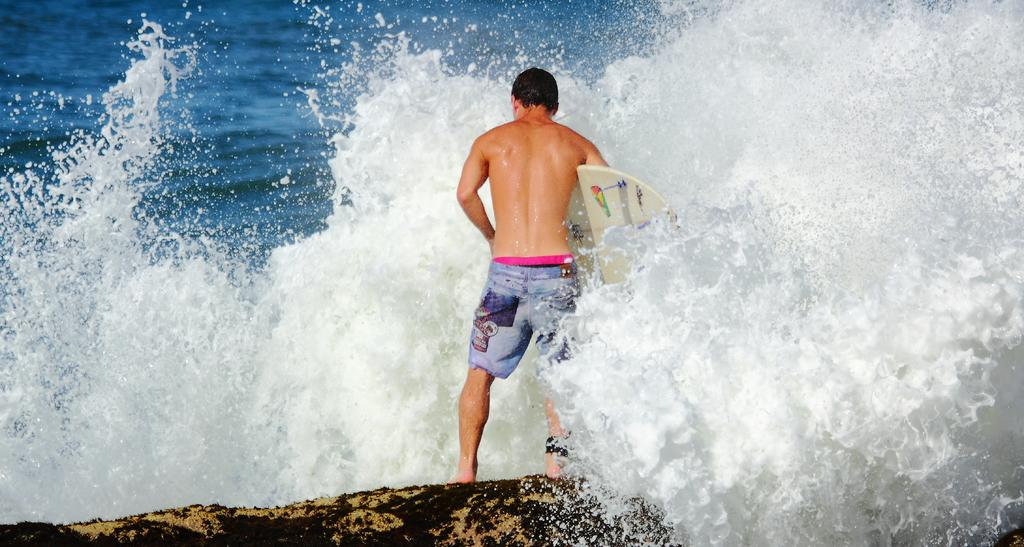Who is present in the image? There is a man in the image. What is the man holding in the image? The man is holding a surfboard. What is the man's posture in the image? The man is standing in the image. What can be seen in the background of the image? There is water visible in the background of the image. What type of argument is the man having with the brush in the image? There is no brush or argument present in the image; the man is holding a surfboard and standing near water. 